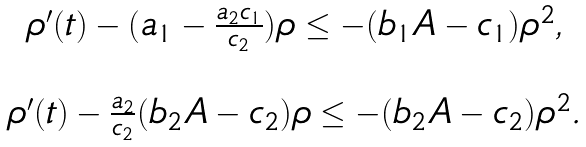<formula> <loc_0><loc_0><loc_500><loc_500>\begin{array} { c } \rho ^ { \prime } ( t ) - ( a _ { 1 } - \frac { a _ { 2 } c _ { 1 } } { c _ { 2 } } ) \rho \leq - ( b _ { 1 } A - c _ { 1 } ) \rho ^ { 2 } , \\ \\ \rho ^ { \prime } ( t ) - \frac { a _ { 2 } } { c _ { 2 } } ( b _ { 2 } A - c _ { 2 } ) \rho \leq - ( b _ { 2 } A - c _ { 2 } ) \rho ^ { 2 } . \end{array}</formula> 